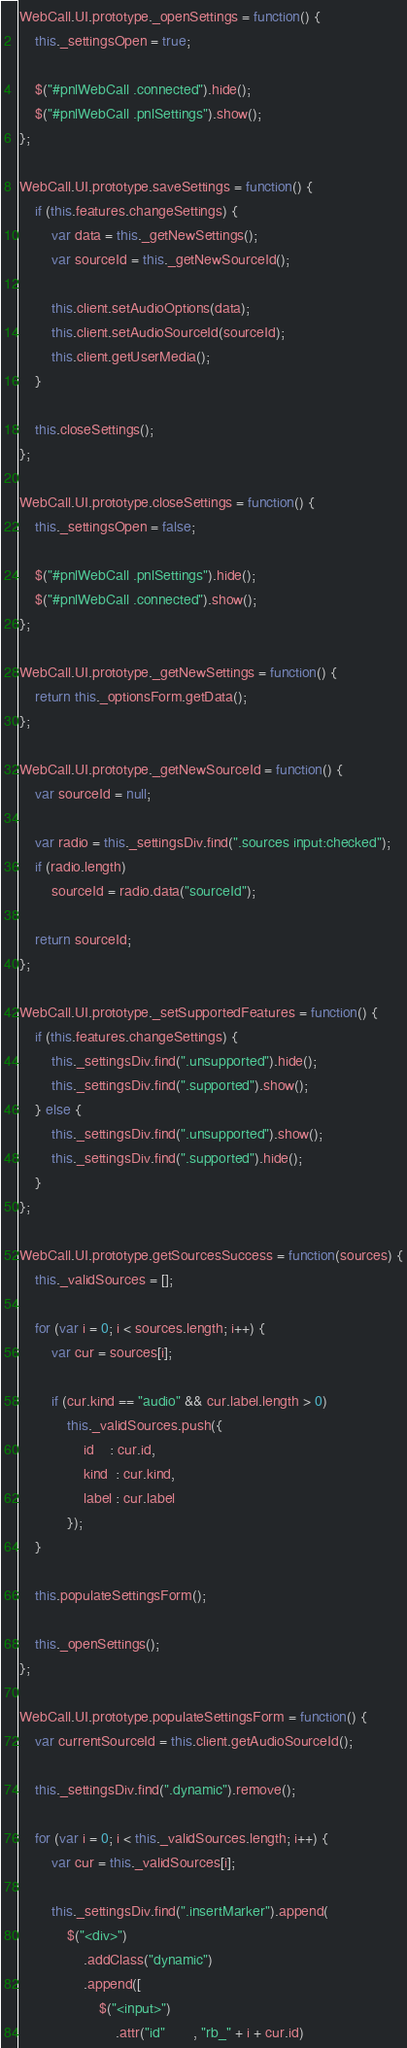<code> <loc_0><loc_0><loc_500><loc_500><_JavaScript_>WebCall.UI.prototype._openSettings = function() {
    this._settingsOpen = true;

    $("#pnlWebCall .connected").hide();
    $("#pnlWebCall .pnlSettings").show();
};

WebCall.UI.prototype.saveSettings = function() {
    if (this.features.changeSettings) {
        var data = this._getNewSettings();
        var sourceId = this._getNewSourceId();

        this.client.setAudioOptions(data);
        this.client.setAudioSourceId(sourceId);
        this.client.getUserMedia();
    }
    
    this.closeSettings();
};

WebCall.UI.prototype.closeSettings = function() {
    this._settingsOpen = false;

    $("#pnlWebCall .pnlSettings").hide();
    $("#pnlWebCall .connected").show();
};

WebCall.UI.prototype._getNewSettings = function() {
    return this._optionsForm.getData();    
};

WebCall.UI.prototype._getNewSourceId = function() {
    var sourceId = null;
               
    var radio = this._settingsDiv.find(".sources input:checked");
    if (radio.length)
        sourceId = radio.data("sourceId");

    return sourceId;
};

WebCall.UI.prototype._setSupportedFeatures = function() {
    if (this.features.changeSettings) {
        this._settingsDiv.find(".unsupported").hide();
        this._settingsDiv.find(".supported").show();
    } else {
        this._settingsDiv.find(".unsupported").show();
        this._settingsDiv.find(".supported").hide();
    }
};

WebCall.UI.prototype.getSourcesSuccess = function(sources) {
    this._validSources = [];

    for (var i = 0; i < sources.length; i++) {
        var cur = sources[i];

        if (cur.kind == "audio" && cur.label.length > 0)
            this._validSources.push({
                id    : cur.id,
                kind  : cur.kind,
                label : cur.label
            });
    }

    this.populateSettingsForm();

    this._openSettings();
};

WebCall.UI.prototype.populateSettingsForm = function() {
    var currentSourceId = this.client.getAudioSourceId();

    this._settingsDiv.find(".dynamic").remove();

    for (var i = 0; i < this._validSources.length; i++) {
        var cur = this._validSources[i];

        this._settingsDiv.find(".insertMarker").append(
            $("<div>")
                .addClass("dynamic")
                .append([
                    $("<input>")
                        .attr("id"       , "rb_" + i + cur.id)</code> 